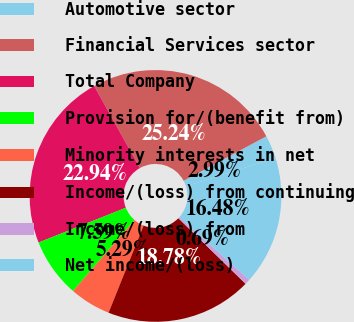Convert chart to OTSL. <chart><loc_0><loc_0><loc_500><loc_500><pie_chart><fcel>Automotive sector<fcel>Financial Services sector<fcel>Total Company<fcel>Provision for/(benefit from)<fcel>Minority interests in net<fcel>Income/(loss) from continuing<fcel>Income/(loss) from<fcel>Net income/(loss)<nl><fcel>2.99%<fcel>25.24%<fcel>22.94%<fcel>7.59%<fcel>5.29%<fcel>18.78%<fcel>0.69%<fcel>16.48%<nl></chart> 